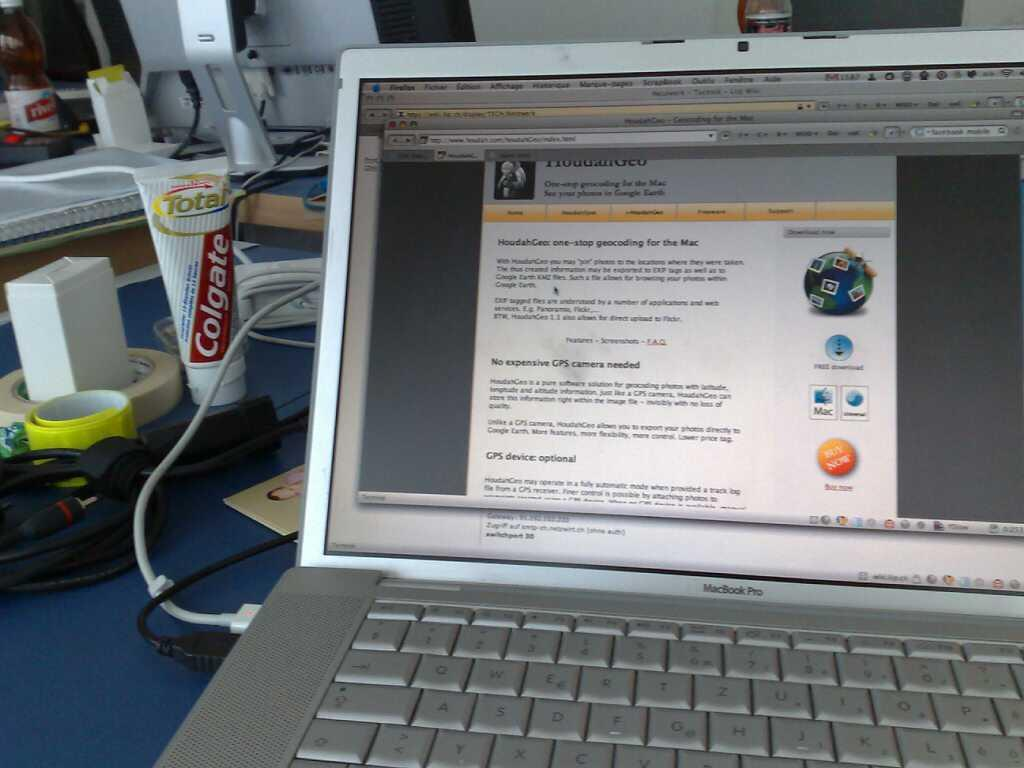<image>
Offer a succinct explanation of the picture presented. Total Colgate toothpaste behind the Macbook Pro laptop. 